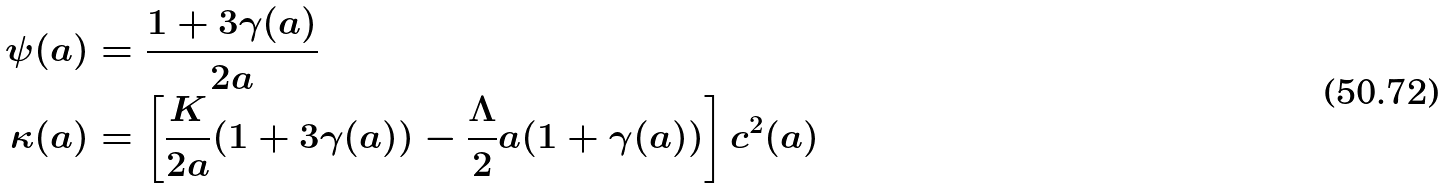Convert formula to latex. <formula><loc_0><loc_0><loc_500><loc_500>\psi ( a ) & = \frac { 1 + 3 \gamma ( a ) } { 2 a } \\ \kappa ( a ) & = \left [ \frac { K } { 2 a } ( 1 + 3 \gamma ( a ) ) - \frac { \Lambda } { 2 } a ( 1 + \gamma ( a ) ) \right ] c ^ { 2 } ( a )</formula> 